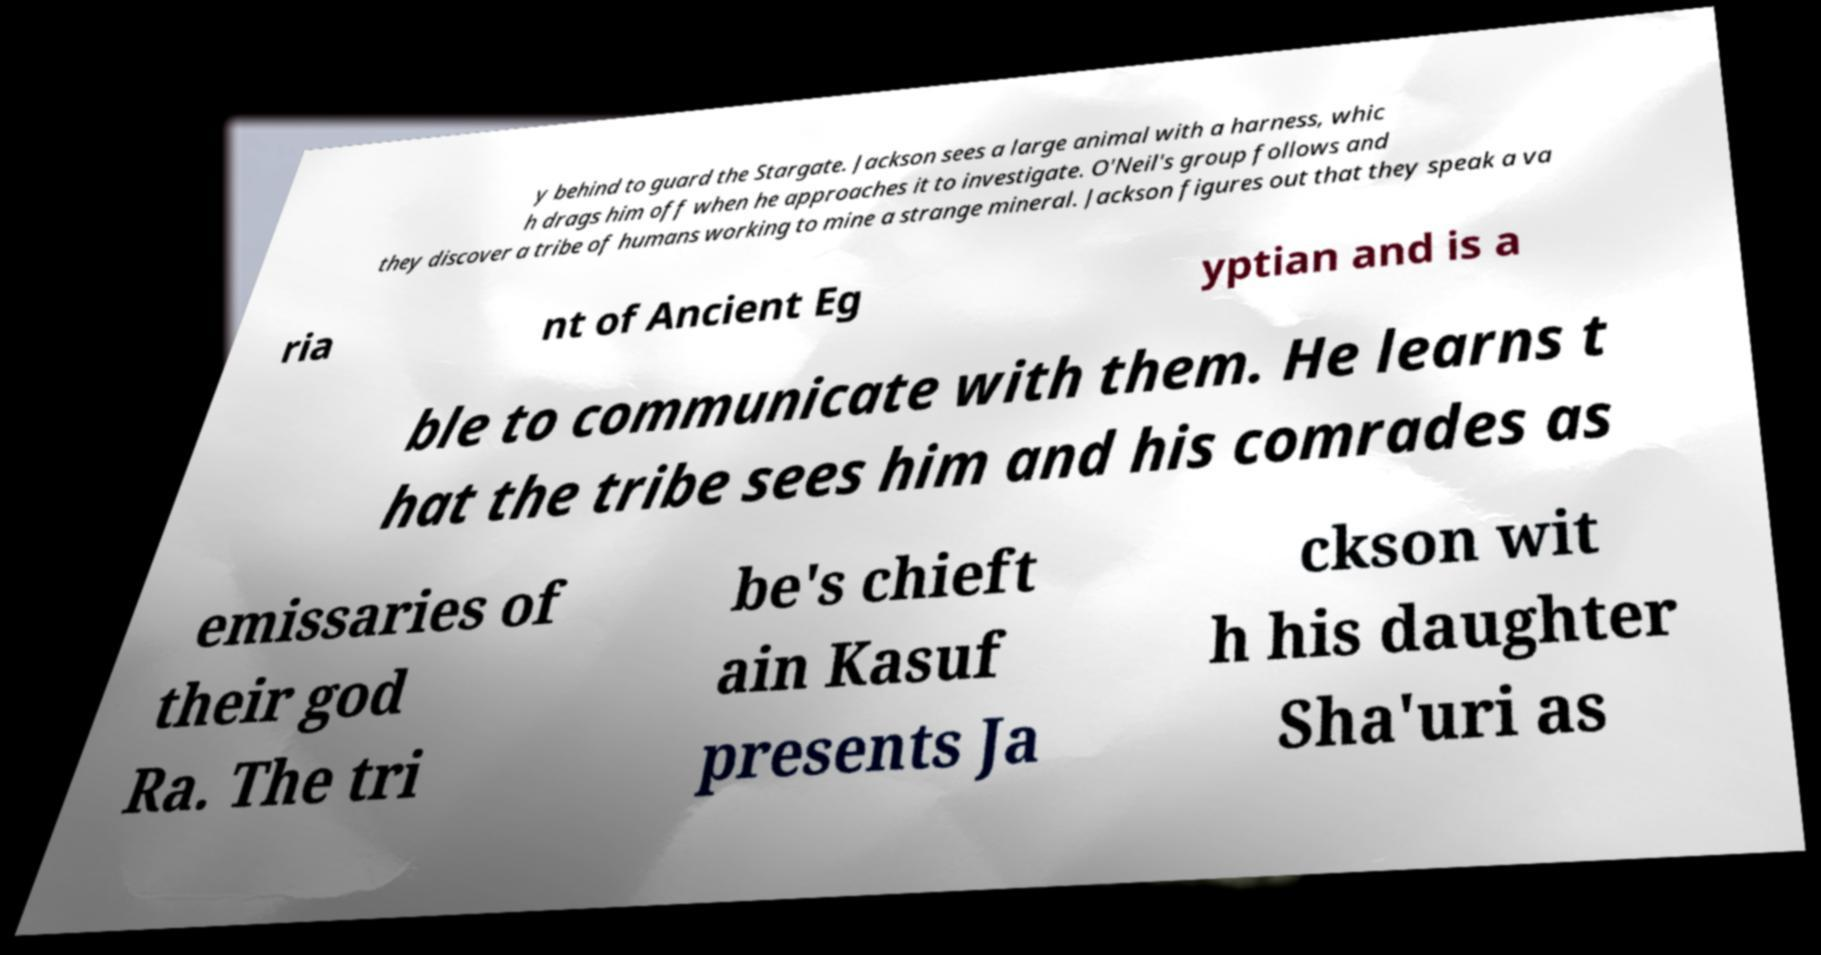There's text embedded in this image that I need extracted. Can you transcribe it verbatim? y behind to guard the Stargate. Jackson sees a large animal with a harness, whic h drags him off when he approaches it to investigate. O'Neil's group follows and they discover a tribe of humans working to mine a strange mineral. Jackson figures out that they speak a va ria nt of Ancient Eg yptian and is a ble to communicate with them. He learns t hat the tribe sees him and his comrades as emissaries of their god Ra. The tri be's chieft ain Kasuf presents Ja ckson wit h his daughter Sha'uri as 